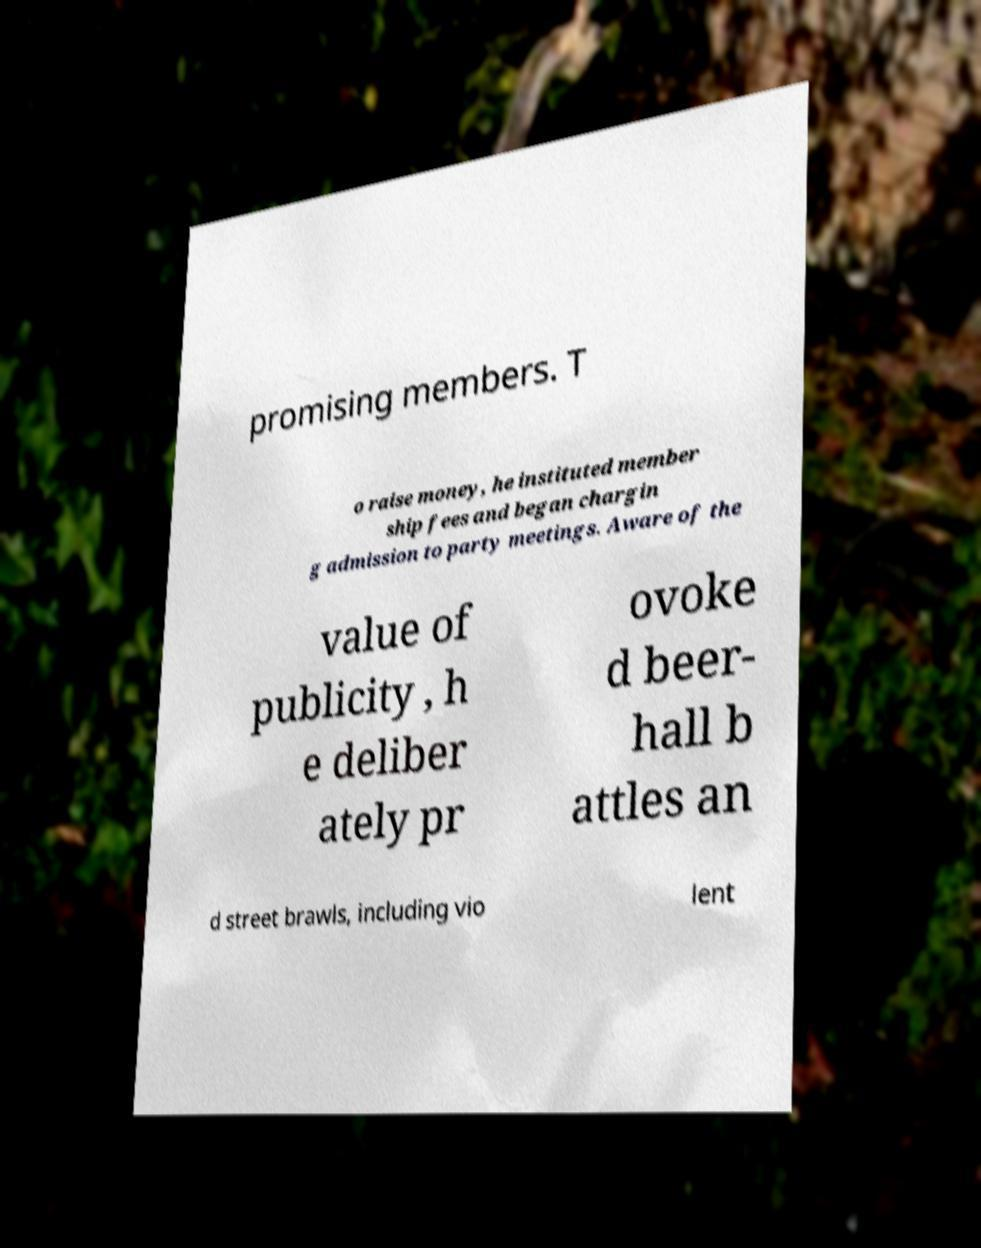Can you read and provide the text displayed in the image?This photo seems to have some interesting text. Can you extract and type it out for me? promising members. T o raise money, he instituted member ship fees and began chargin g admission to party meetings. Aware of the value of publicity , h e deliber ately pr ovoke d beer- hall b attles an d street brawls, including vio lent 